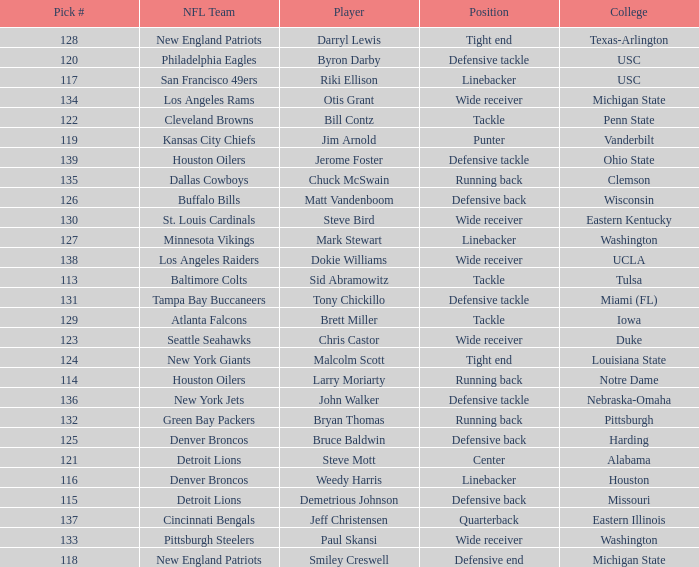What pick number did the buffalo bills get? 126.0. Can you give me this table as a dict? {'header': ['Pick #', 'NFL Team', 'Player', 'Position', 'College'], 'rows': [['128', 'New England Patriots', 'Darryl Lewis', 'Tight end', 'Texas-Arlington'], ['120', 'Philadelphia Eagles', 'Byron Darby', 'Defensive tackle', 'USC'], ['117', 'San Francisco 49ers', 'Riki Ellison', 'Linebacker', 'USC'], ['134', 'Los Angeles Rams', 'Otis Grant', 'Wide receiver', 'Michigan State'], ['122', 'Cleveland Browns', 'Bill Contz', 'Tackle', 'Penn State'], ['119', 'Kansas City Chiefs', 'Jim Arnold', 'Punter', 'Vanderbilt'], ['139', 'Houston Oilers', 'Jerome Foster', 'Defensive tackle', 'Ohio State'], ['135', 'Dallas Cowboys', 'Chuck McSwain', 'Running back', 'Clemson'], ['126', 'Buffalo Bills', 'Matt Vandenboom', 'Defensive back', 'Wisconsin'], ['130', 'St. Louis Cardinals', 'Steve Bird', 'Wide receiver', 'Eastern Kentucky'], ['127', 'Minnesota Vikings', 'Mark Stewart', 'Linebacker', 'Washington'], ['138', 'Los Angeles Raiders', 'Dokie Williams', 'Wide receiver', 'UCLA'], ['113', 'Baltimore Colts', 'Sid Abramowitz', 'Tackle', 'Tulsa'], ['131', 'Tampa Bay Buccaneers', 'Tony Chickillo', 'Defensive tackle', 'Miami (FL)'], ['129', 'Atlanta Falcons', 'Brett Miller', 'Tackle', 'Iowa'], ['123', 'Seattle Seahawks', 'Chris Castor', 'Wide receiver', 'Duke'], ['124', 'New York Giants', 'Malcolm Scott', 'Tight end', 'Louisiana State'], ['114', 'Houston Oilers', 'Larry Moriarty', 'Running back', 'Notre Dame'], ['136', 'New York Jets', 'John Walker', 'Defensive tackle', 'Nebraska-Omaha'], ['132', 'Green Bay Packers', 'Bryan Thomas', 'Running back', 'Pittsburgh'], ['125', 'Denver Broncos', 'Bruce Baldwin', 'Defensive back', 'Harding'], ['121', 'Detroit Lions', 'Steve Mott', 'Center', 'Alabama'], ['116', 'Denver Broncos', 'Weedy Harris', 'Linebacker', 'Houston'], ['115', 'Detroit Lions', 'Demetrious Johnson', 'Defensive back', 'Missouri'], ['137', 'Cincinnati Bengals', 'Jeff Christensen', 'Quarterback', 'Eastern Illinois'], ['133', 'Pittsburgh Steelers', 'Paul Skansi', 'Wide receiver', 'Washington'], ['118', 'New England Patriots', 'Smiley Creswell', 'Defensive end', 'Michigan State']]} 